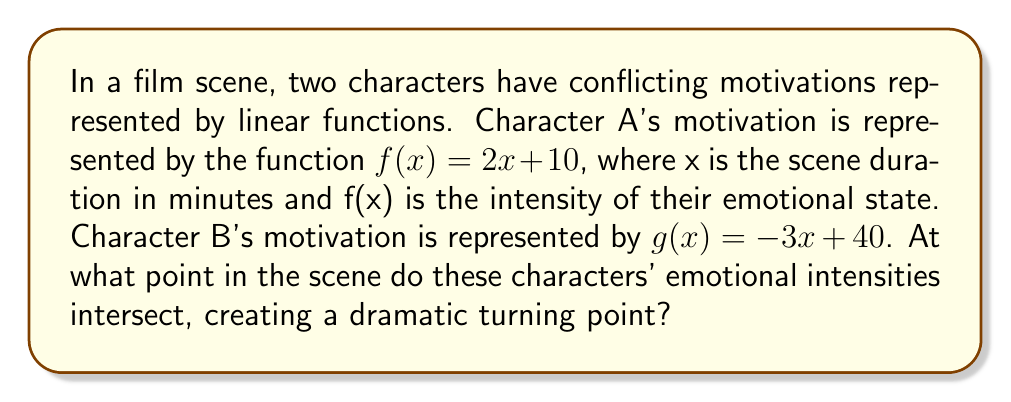Give your solution to this math problem. To find the intersection of these two linear functions, we need to solve the equation:

$$f(x) = g(x)$$

Substituting the given functions:

$$2x + 10 = -3x + 40$$

Now, let's solve this equation step by step:

1) Add 3x to both sides:
   $$5x + 10 = 40$$

2) Subtract 10 from both sides:
   $$5x = 30$$

3) Divide both sides by 5:
   $$x = 6$$

This means the functions intersect when $x = 6$. To find the y-coordinate (emotional intensity) at this point, we can substitute x = 6 into either function. Let's use f(x):

$$f(6) = 2(6) + 10 = 12 + 10 = 22$$

Therefore, the intersection point is (6, 22). This means the characters' emotional intensities intersect 6 minutes into the scene, at an intensity level of 22.
Answer: (6, 22) 